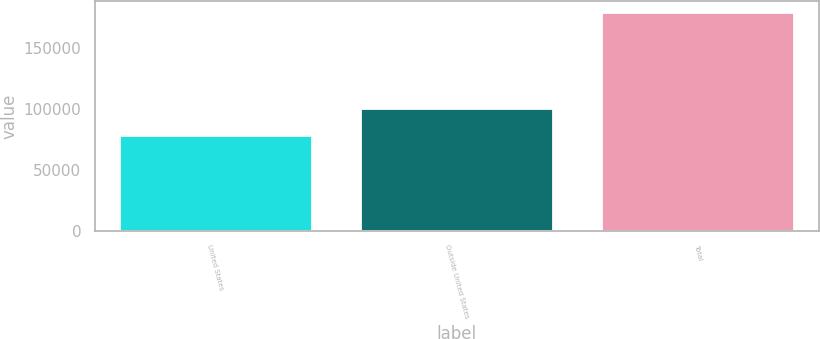Convert chart. <chart><loc_0><loc_0><loc_500><loc_500><bar_chart><fcel>United States<fcel>Outside United States<fcel>Total<nl><fcel>78593<fcel>101126<fcel>179719<nl></chart> 